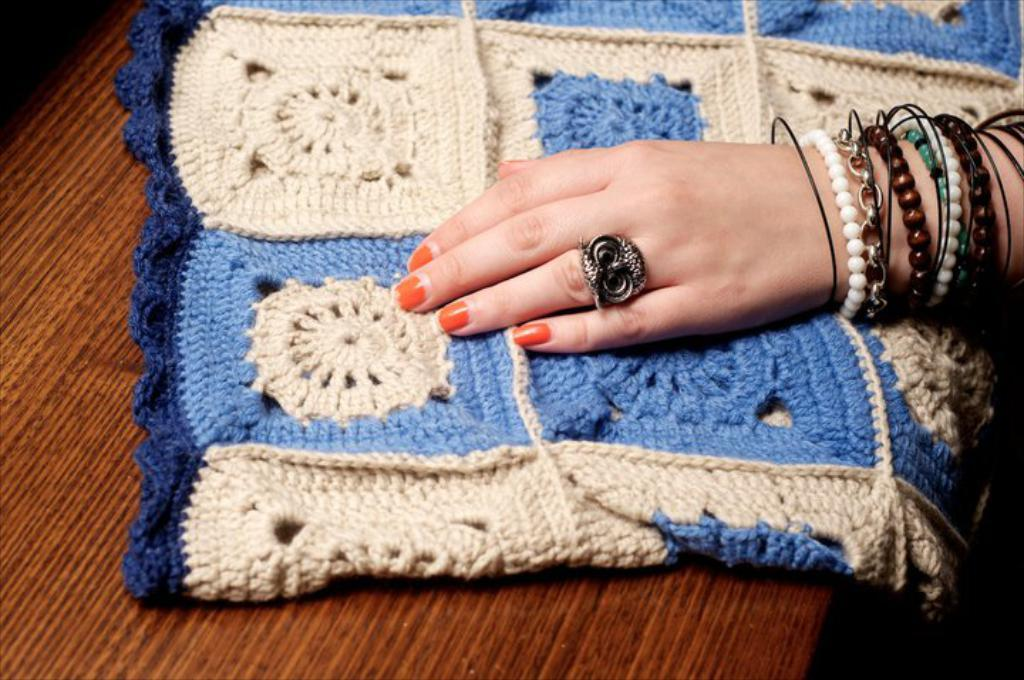What type of furniture is present in the image? There is a table in the image. Where is the table located in the image? The table is at the bottom of the image. What is covering the table in the image? There is a cloth on the table. What part of a person can be seen in the image? There is a human hand on the right side of the image. What type of coat is the kitten wearing in the image? There is no kitten or coat present in the image. What is the cause of the war depicted in the image? There is no war depicted in the image; it only features a table, a cloth, and a human hand. 